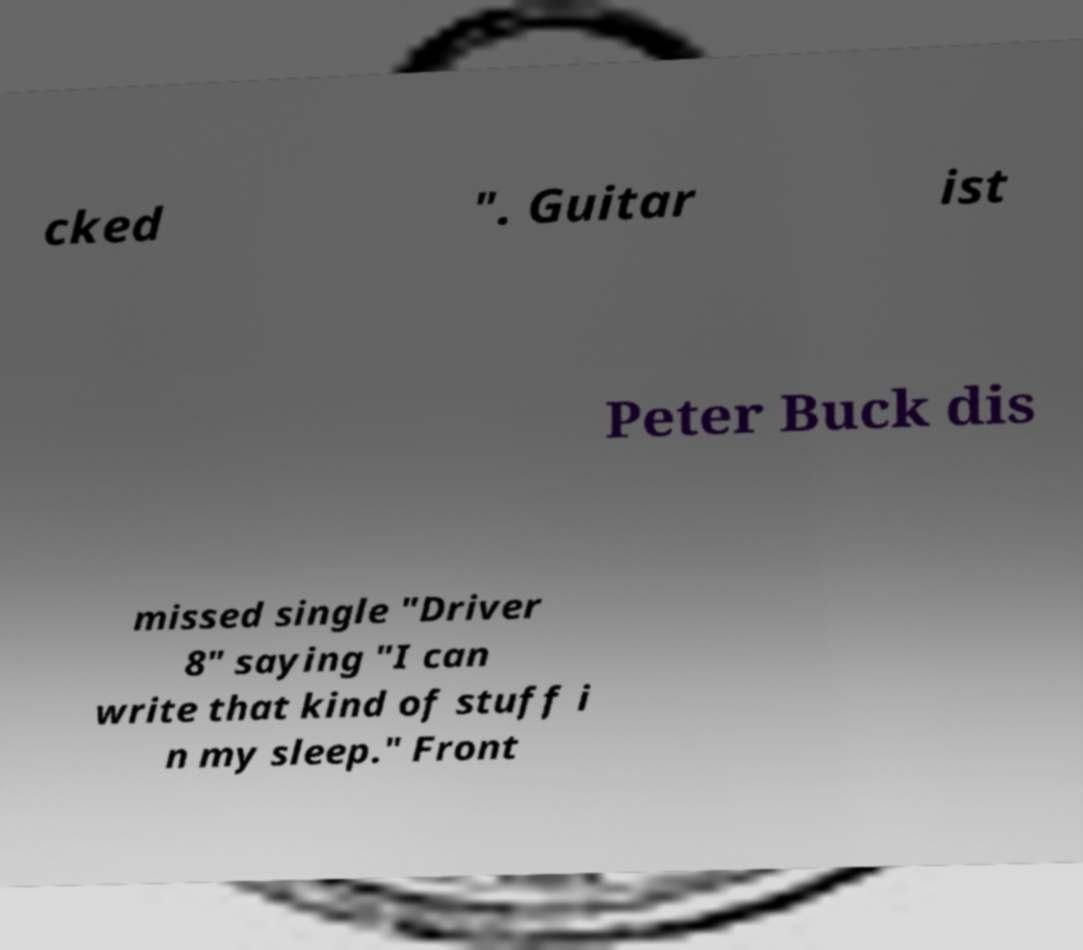Could you extract and type out the text from this image? cked ". Guitar ist Peter Buck dis missed single "Driver 8" saying "I can write that kind of stuff i n my sleep." Front 